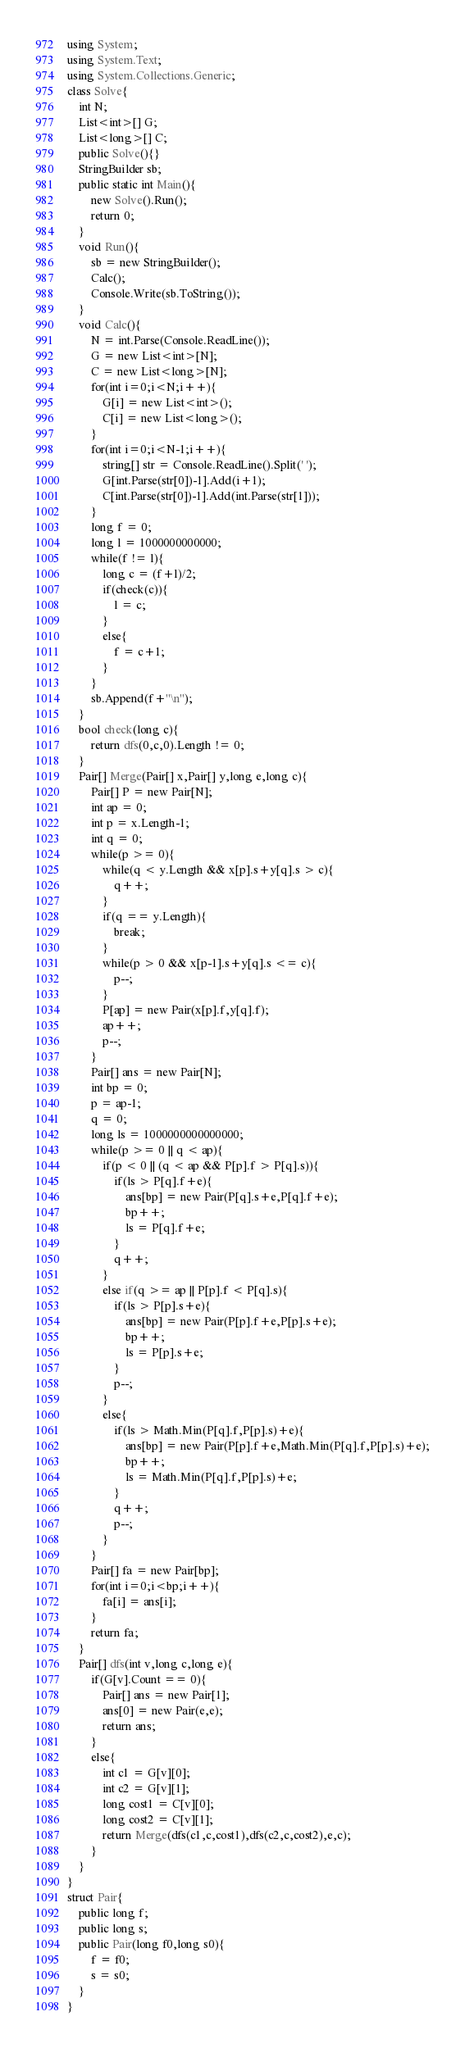<code> <loc_0><loc_0><loc_500><loc_500><_C#_>using System;
using System.Text;
using System.Collections.Generic;
class Solve{
    int N;
    List<int>[] G;
    List<long>[] C;
    public Solve(){}
    StringBuilder sb;
    public static int Main(){
        new Solve().Run();
        return 0;
    }
    void Run(){
        sb = new StringBuilder();
        Calc();
        Console.Write(sb.ToString());
    }
    void Calc(){
        N = int.Parse(Console.ReadLine());
        G = new List<int>[N];
        C = new List<long>[N];
        for(int i=0;i<N;i++){
            G[i] = new List<int>();
            C[i] = new List<long>();
        }
        for(int i=0;i<N-1;i++){
            string[] str = Console.ReadLine().Split(' ');
            G[int.Parse(str[0])-1].Add(i+1);
            C[int.Parse(str[0])-1].Add(int.Parse(str[1]));
        }
        long f = 0;
        long l = 1000000000000;
        while(f != l){
            long c = (f+l)/2;
            if(check(c)){
                l = c;
            }
            else{
                f = c+1;
            }
        }
        sb.Append(f+"\n");
    }
    bool check(long c){
        return dfs(0,c,0).Length != 0;
    }
    Pair[] Merge(Pair[] x,Pair[] y,long e,long c){
        Pair[] P = new Pair[N];
        int ap = 0;
        int p = x.Length-1;
        int q = 0;
        while(p >= 0){
            while(q < y.Length && x[p].s+y[q].s > c){
                q++;
            }
            if(q == y.Length){
                break;
            }
            while(p > 0 && x[p-1].s+y[q].s <= c){
                p--;
            }
            P[ap] = new Pair(x[p].f,y[q].f);
            ap++;
            p--;
        }
        Pair[] ans = new Pair[N];
        int bp = 0;
        p = ap-1;
        q = 0;
        long ls = 1000000000000000;
        while(p >= 0 || q < ap){
            if(p < 0 || (q < ap && P[p].f > P[q].s)){
                if(ls > P[q].f+e){
                    ans[bp] = new Pair(P[q].s+e,P[q].f+e);
                    bp++;
                    ls = P[q].f+e;
                }
                q++;
            }
            else if(q >= ap || P[p].f < P[q].s){
                if(ls > P[p].s+e){
                    ans[bp] = new Pair(P[p].f+e,P[p].s+e);
                    bp++;
                    ls = P[p].s+e;
                }
                p--;
            }
            else{
                if(ls > Math.Min(P[q].f,P[p].s)+e){
                    ans[bp] = new Pair(P[p].f+e,Math.Min(P[q].f,P[p].s)+e);
                    bp++;
                    ls = Math.Min(P[q].f,P[p].s)+e;
                }
                q++;
                p--;
            }
        }
        Pair[] fa = new Pair[bp];
        for(int i=0;i<bp;i++){
            fa[i] = ans[i];
        }
        return fa;
    }
    Pair[] dfs(int v,long c,long e){
        if(G[v].Count == 0){
            Pair[] ans = new Pair[1];
            ans[0] = new Pair(e,e);
            return ans;
        }
        else{
            int c1 = G[v][0];
            int c2 = G[v][1];
            long cost1 = C[v][0];
            long cost2 = C[v][1];
            return Merge(dfs(c1,c,cost1),dfs(c2,c,cost2),e,c);
        }
    }
}
struct Pair{
    public long f;
    public long s;
    public Pair(long f0,long s0){
        f = f0;
        s = s0;
    }
}</code> 